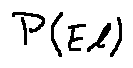<formula> <loc_0><loc_0><loc_500><loc_500>P ( E l )</formula> 